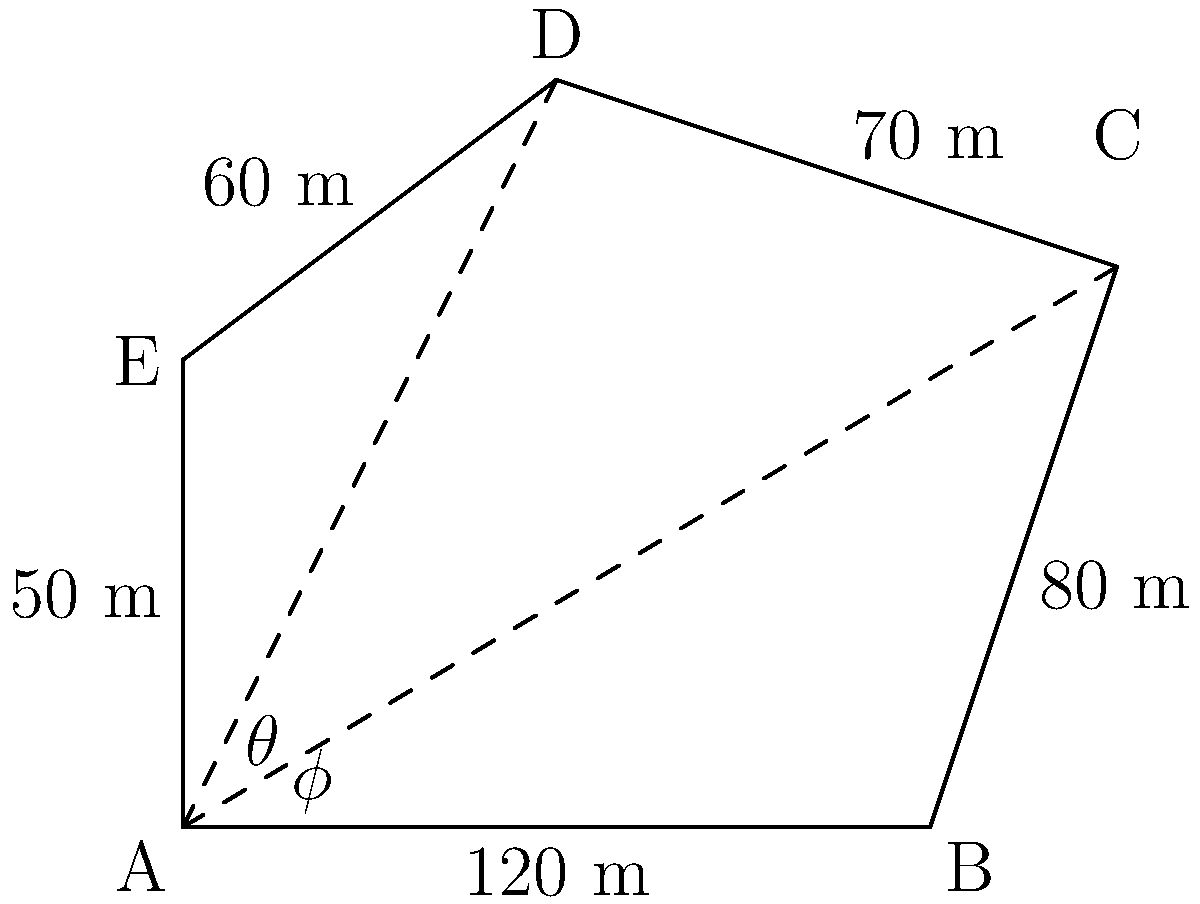An irregular-shaped agricultural plot is represented by the pentagon ABCDE. Given that AB = 120 m, BC = 80 m, CD = 70 m, DE = 60 m, and EA = 50 m, and the angles θ and φ at vertex A are 30° and 45° respectively, calculate the total area of the plot. How might this information be useful in estimating the carbon sequestration potential of this agricultural land? To calculate the area of the irregular pentagon, we can divide it into three triangles: ABC, ACD, and ADE. We'll use the trigonometric area formula for triangles: $Area = \frac{1}{2} \cdot base \cdot height$.

1. For triangle ABC:
   Base (AB) = 120 m
   Angle θ = 30°
   Height = 120 · sin(30°) = 60 m
   Area_ABC = $\frac{1}{2} \cdot 120 \cdot 60 = 3600$ m²

2. For triangle ACD:
   We need to find AC first using the cosine law:
   $AC^2 = AB^2 + BC^2 - 2(AB)(BC)cos(θ)$
   $AC^2 = 120^2 + 80^2 - 2(120)(80)cos(30°)$
   $AC = \sqrt{22400 + 16600} = \sqrt{39000} \approx 197.48$ m
   
   Now we can find the area of ACD:
   Angle φ = 45°
   Height = 197.48 · sin(45°) ≈ 139.64 m
   Area_ACD = $\frac{1}{2} \cdot 197.48 \cdot 139.64 \approx 13789.43$ m²

3. For triangle ADE:
   We know two sides (DE = 60 m, EA = 50 m) and the included angle (180° - 30° - 45° = 105°)
   Area_ADE = $\frac{1}{2} \cdot 60 \cdot 50 \cdot sin(105°) \approx 1449.40$ m²

4. Total area = Area_ABC + Area_ACD + Area_ADE
               ≈ 3600 + 13789.43 + 1449.40
               ≈ 18838.83 m²

This information is useful for estimating carbon sequestration potential because the total area of the agricultural land directly affects the amount of carbon that can be sequestered. Knowing the precise area allows for more accurate calculations of potential carbon storage in the soil, which is crucial for developing effective carbon sequestration strategies in agricultural practices.
Answer: 18838.83 m² 